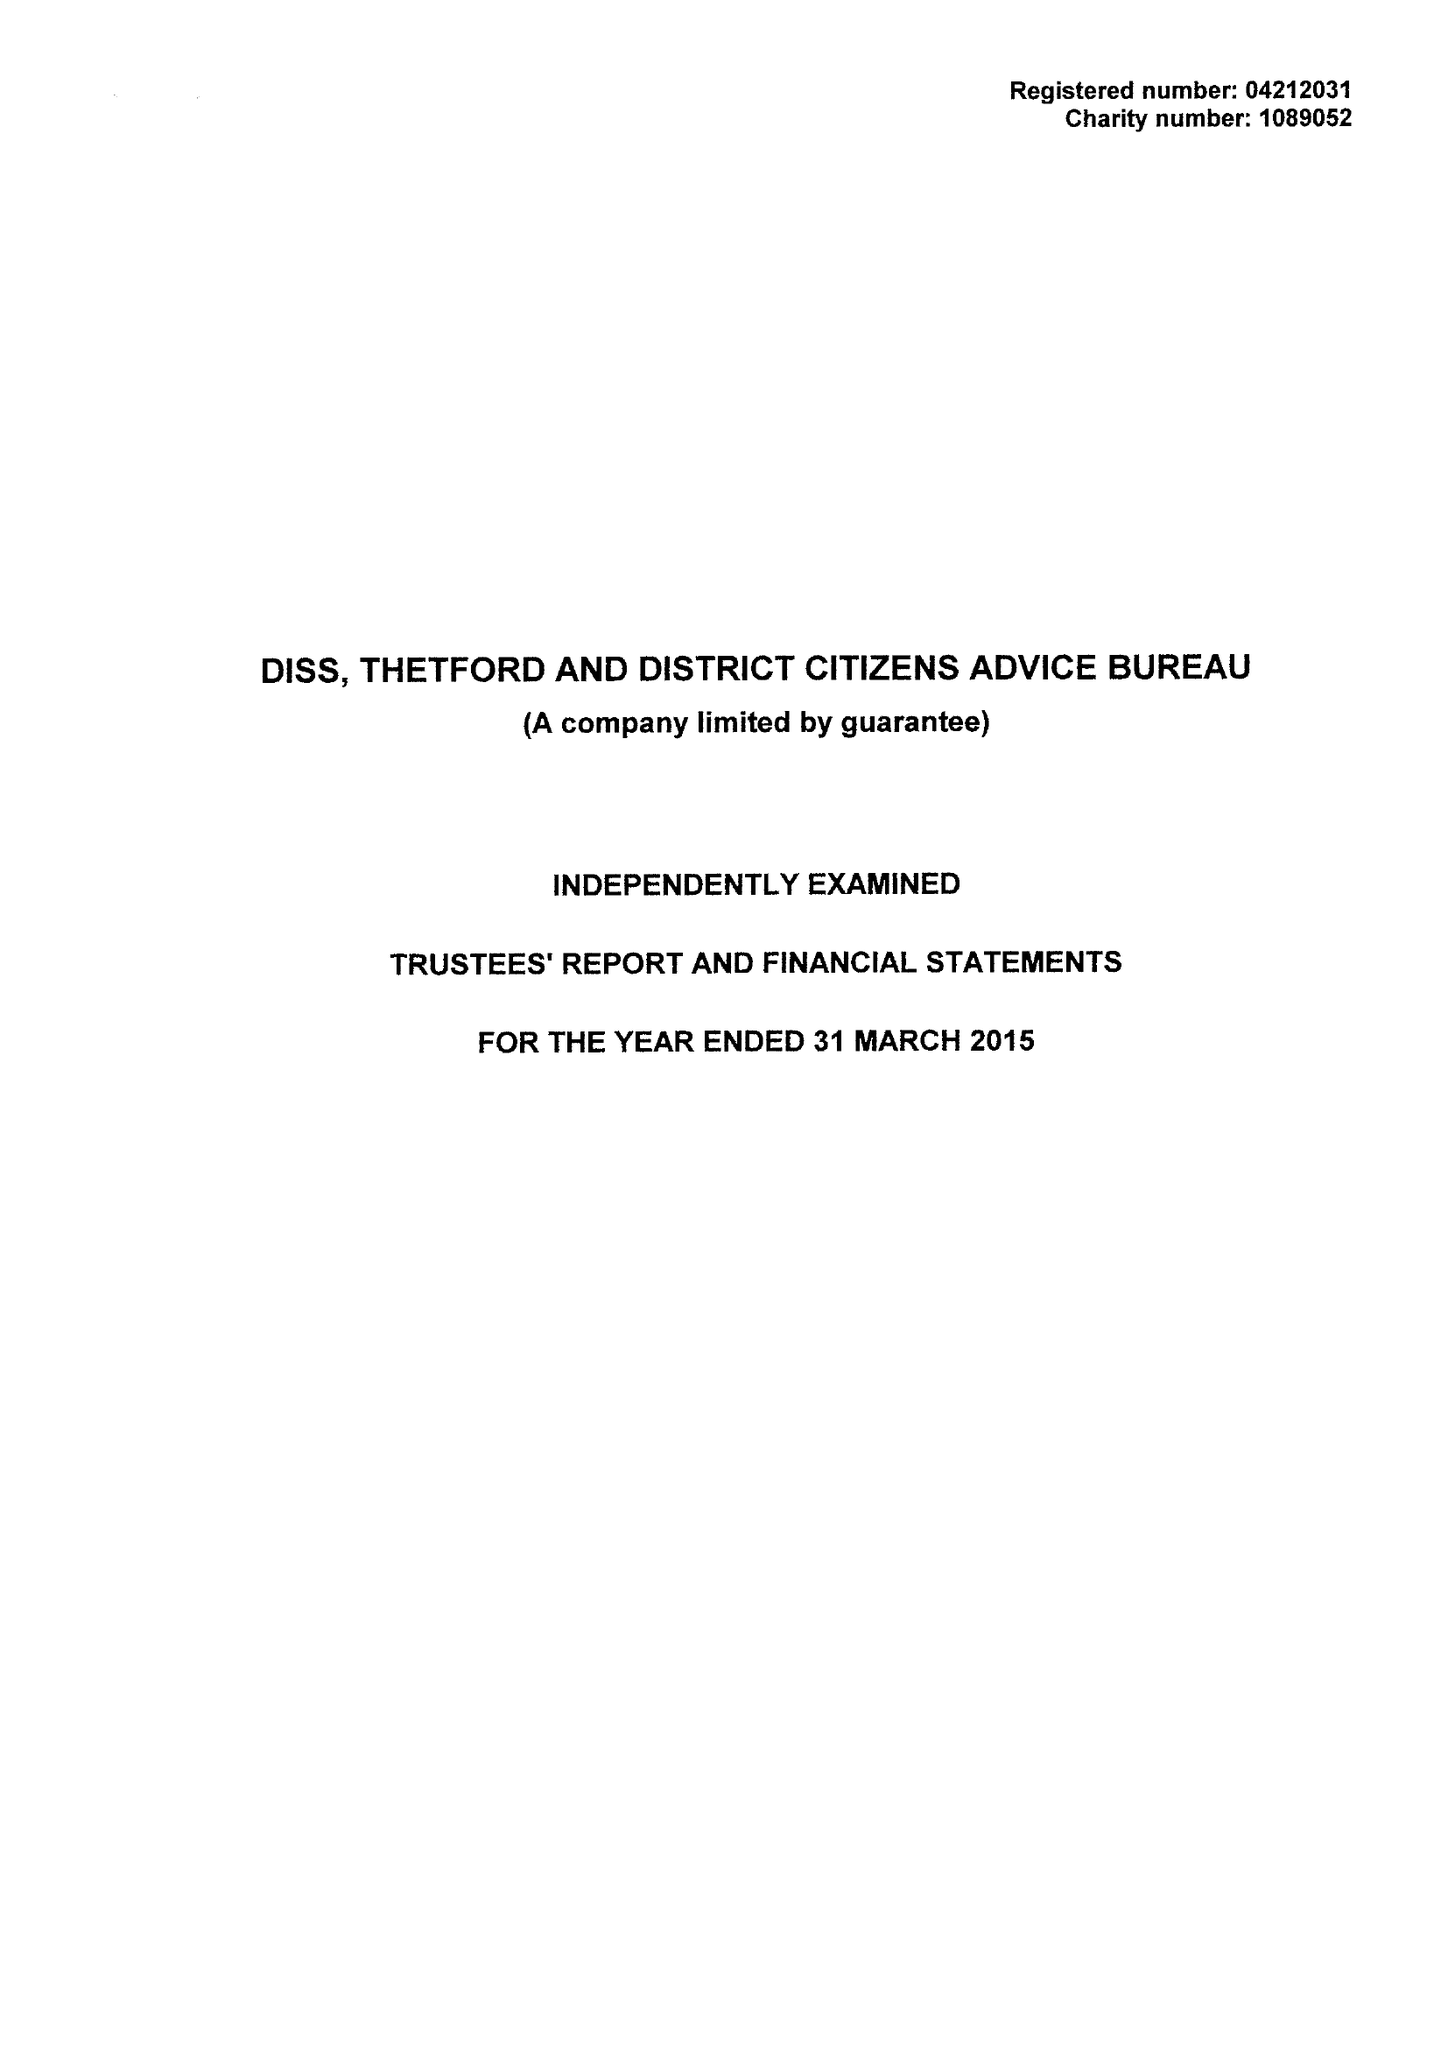What is the value for the charity_number?
Answer the question using a single word or phrase. 1089052 